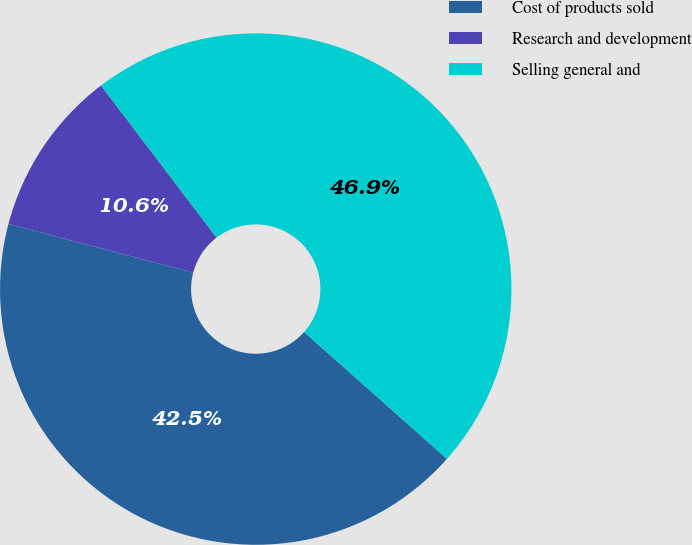<chart> <loc_0><loc_0><loc_500><loc_500><pie_chart><fcel>Cost of products sold<fcel>Research and development<fcel>Selling general and<nl><fcel>42.54%<fcel>10.56%<fcel>46.9%<nl></chart> 